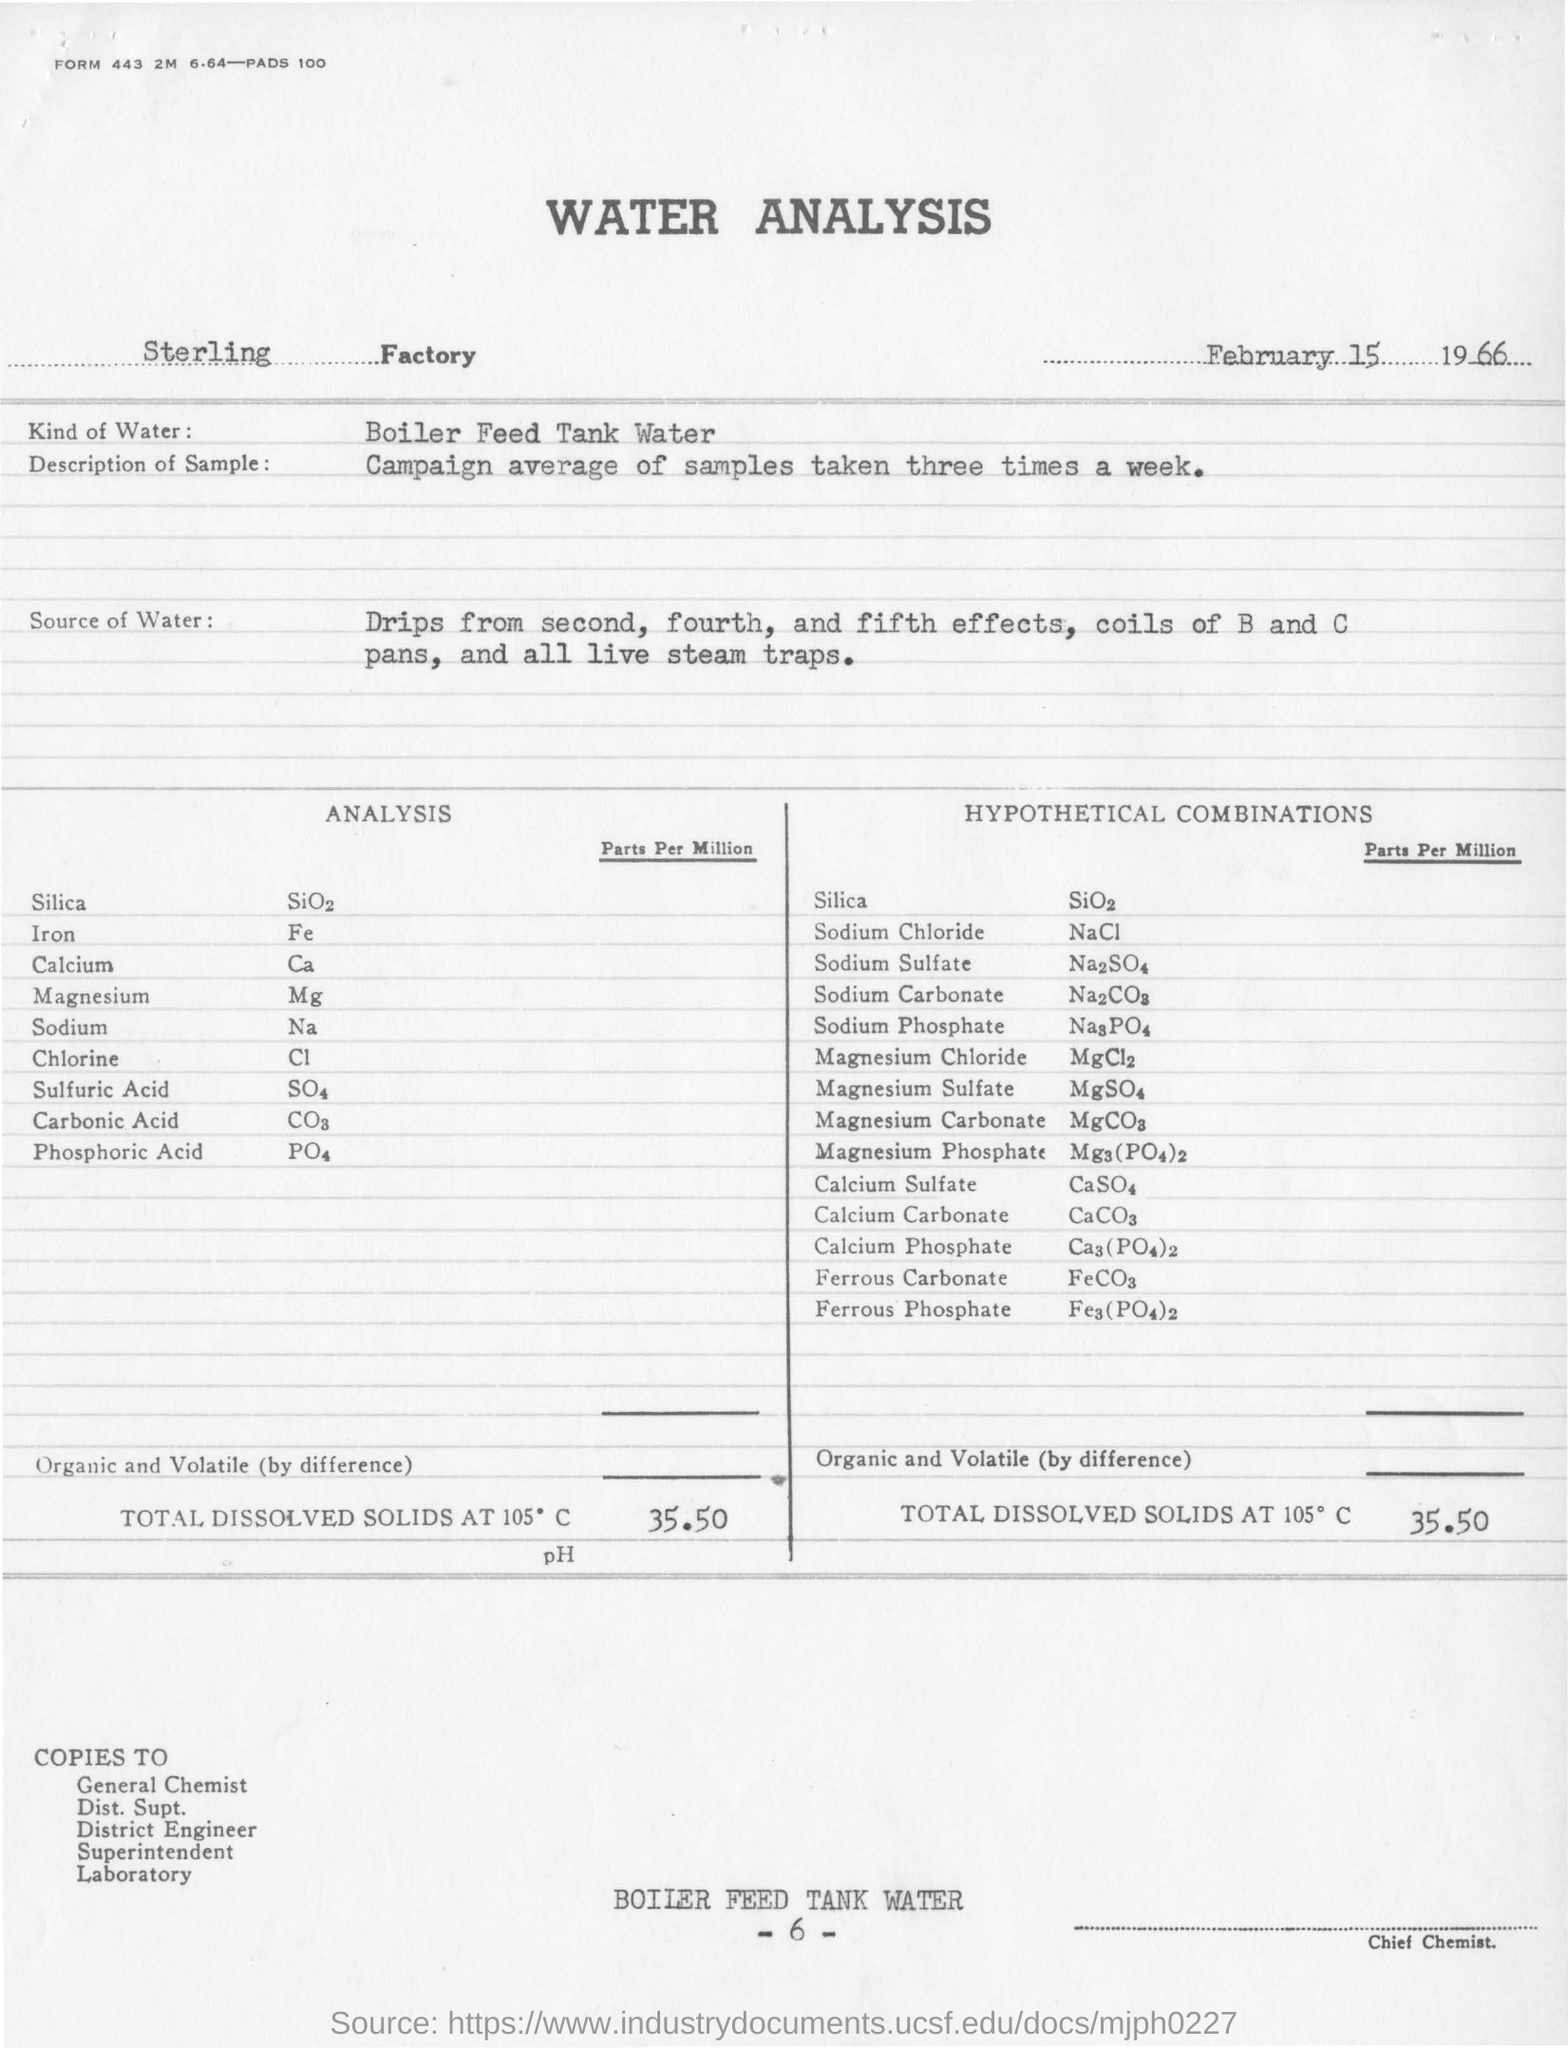How many times in a week campaign average of samples are taken ?
Provide a succinct answer. Three times a week. What kind of water are taken from sterling factory ?
Your answer should be very brief. Boiler Feed Tank Water. What is the first compound  listed under the title of "analysis"?
Give a very brief answer. Silica. What is the total dissolved solids at 105 degree c per per million present in the sample water for hypothetical combination?
Ensure brevity in your answer.  35.50. 